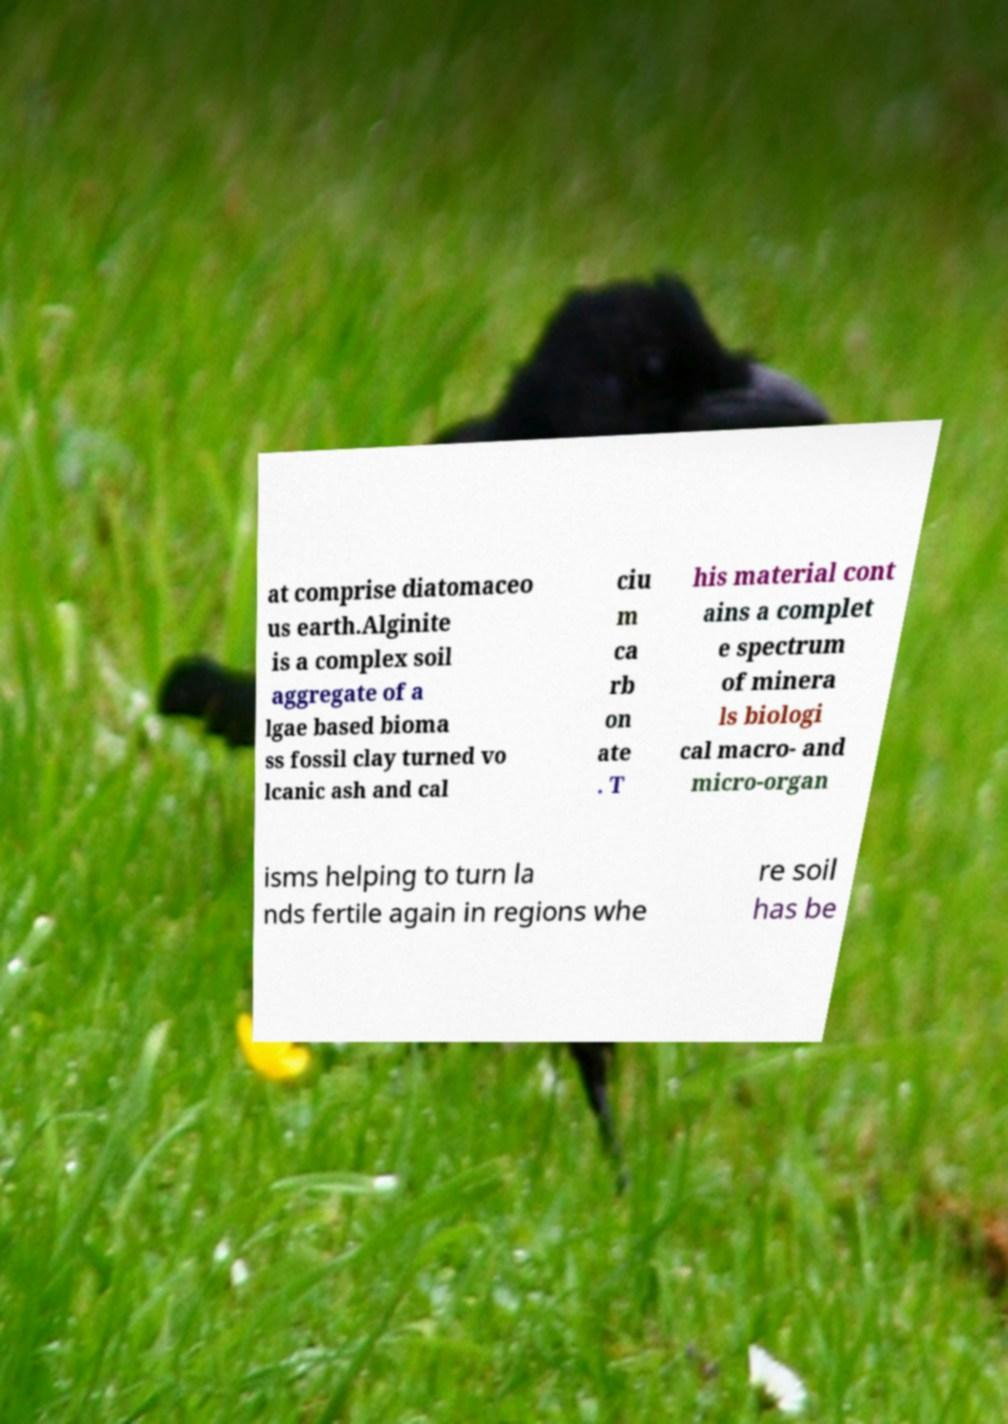I need the written content from this picture converted into text. Can you do that? at comprise diatomaceo us earth.Alginite is a complex soil aggregate of a lgae based bioma ss fossil clay turned vo lcanic ash and cal ciu m ca rb on ate . T his material cont ains a complet e spectrum of minera ls biologi cal macro- and micro-organ isms helping to turn la nds fertile again in regions whe re soil has be 